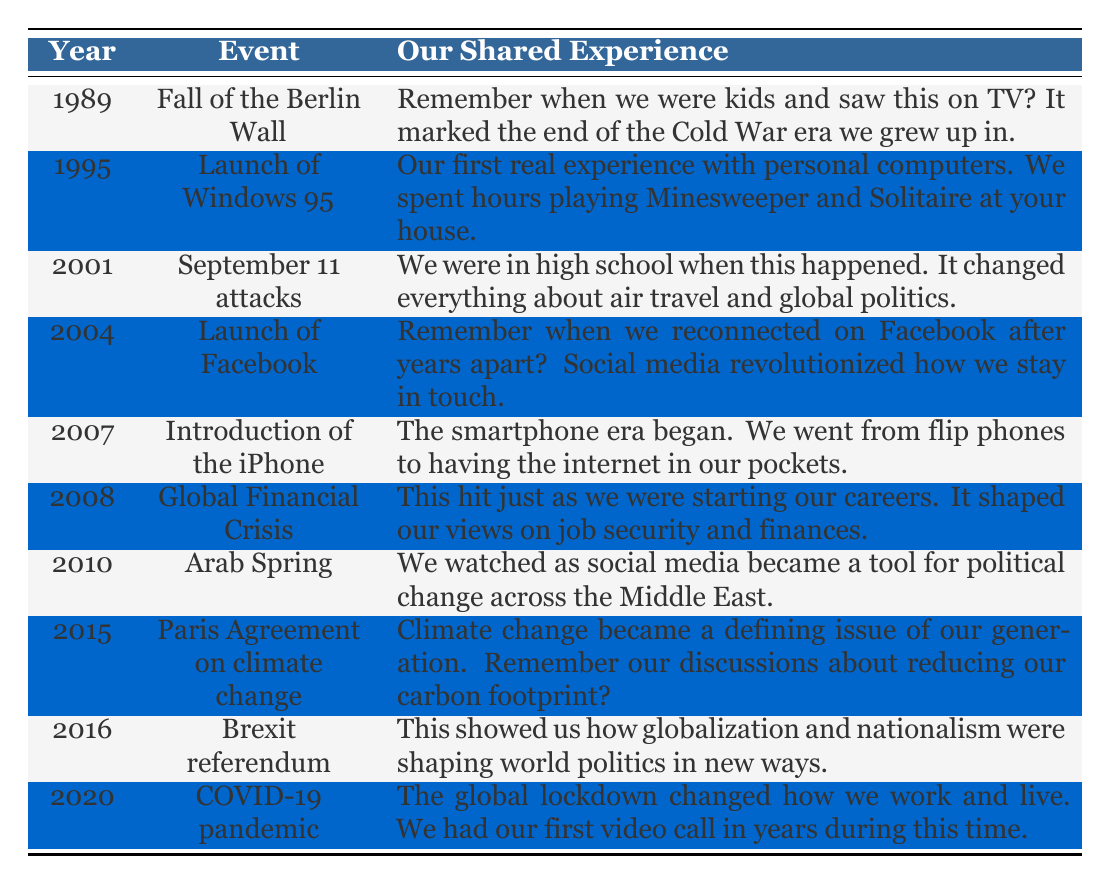What significant event happened in 1989? According to the table, the significant event in 1989 was the Fall of the Berlin Wall. It marked the end of the Cold War era.
Answer: Fall of the Berlin Wall What year was the launch of Windows 95? The table indicates that Windows 95 was launched in 1995.
Answer: 1995 Which event in the timeline occurred after the September 11 attacks? The September 11 attacks occurred in 2001. The next event listed in the table is the launch of Facebook in 2004.
Answer: Launch of Facebook What are the two events that relate to social media? The events related to social media in the table are the launch of Facebook in 2004 and the Arab Spring in 2010, where social media was a tool for change.
Answer: Launch of Facebook and Arab Spring Was the introduction of the iPhone in 2007 significant for the smartphone era? Yes, the table describes the introduction of the iPhone as the beginning of the smartphone era.
Answer: Yes Which event occurred in the year immediately preceding the COVID-19 pandemic? The table states that the COVID-19 pandemic occurred in 2020. The event that occurred immediately before it was Brexit referendum in 2016.
Answer: Brexit referendum What was the first event in the timeline that mentioned a major crisis? The first event mentioned that relates to a major crisis is the Global Financial Crisis in 2008.
Answer: Global Financial Crisis How many years are there between the launch of Facebook and the introduction of the iPhone? Facebook was launched in 2004 and the iPhone was introduced in 2007. The difference is 3 years (2007 - 2004 = 3).
Answer: 3 years Is the year 2015 associated with the Paris Agreement on climate change? Yes, the table confirms that the Paris Agreement on climate change was indeed established in 2015.
Answer: Yes 